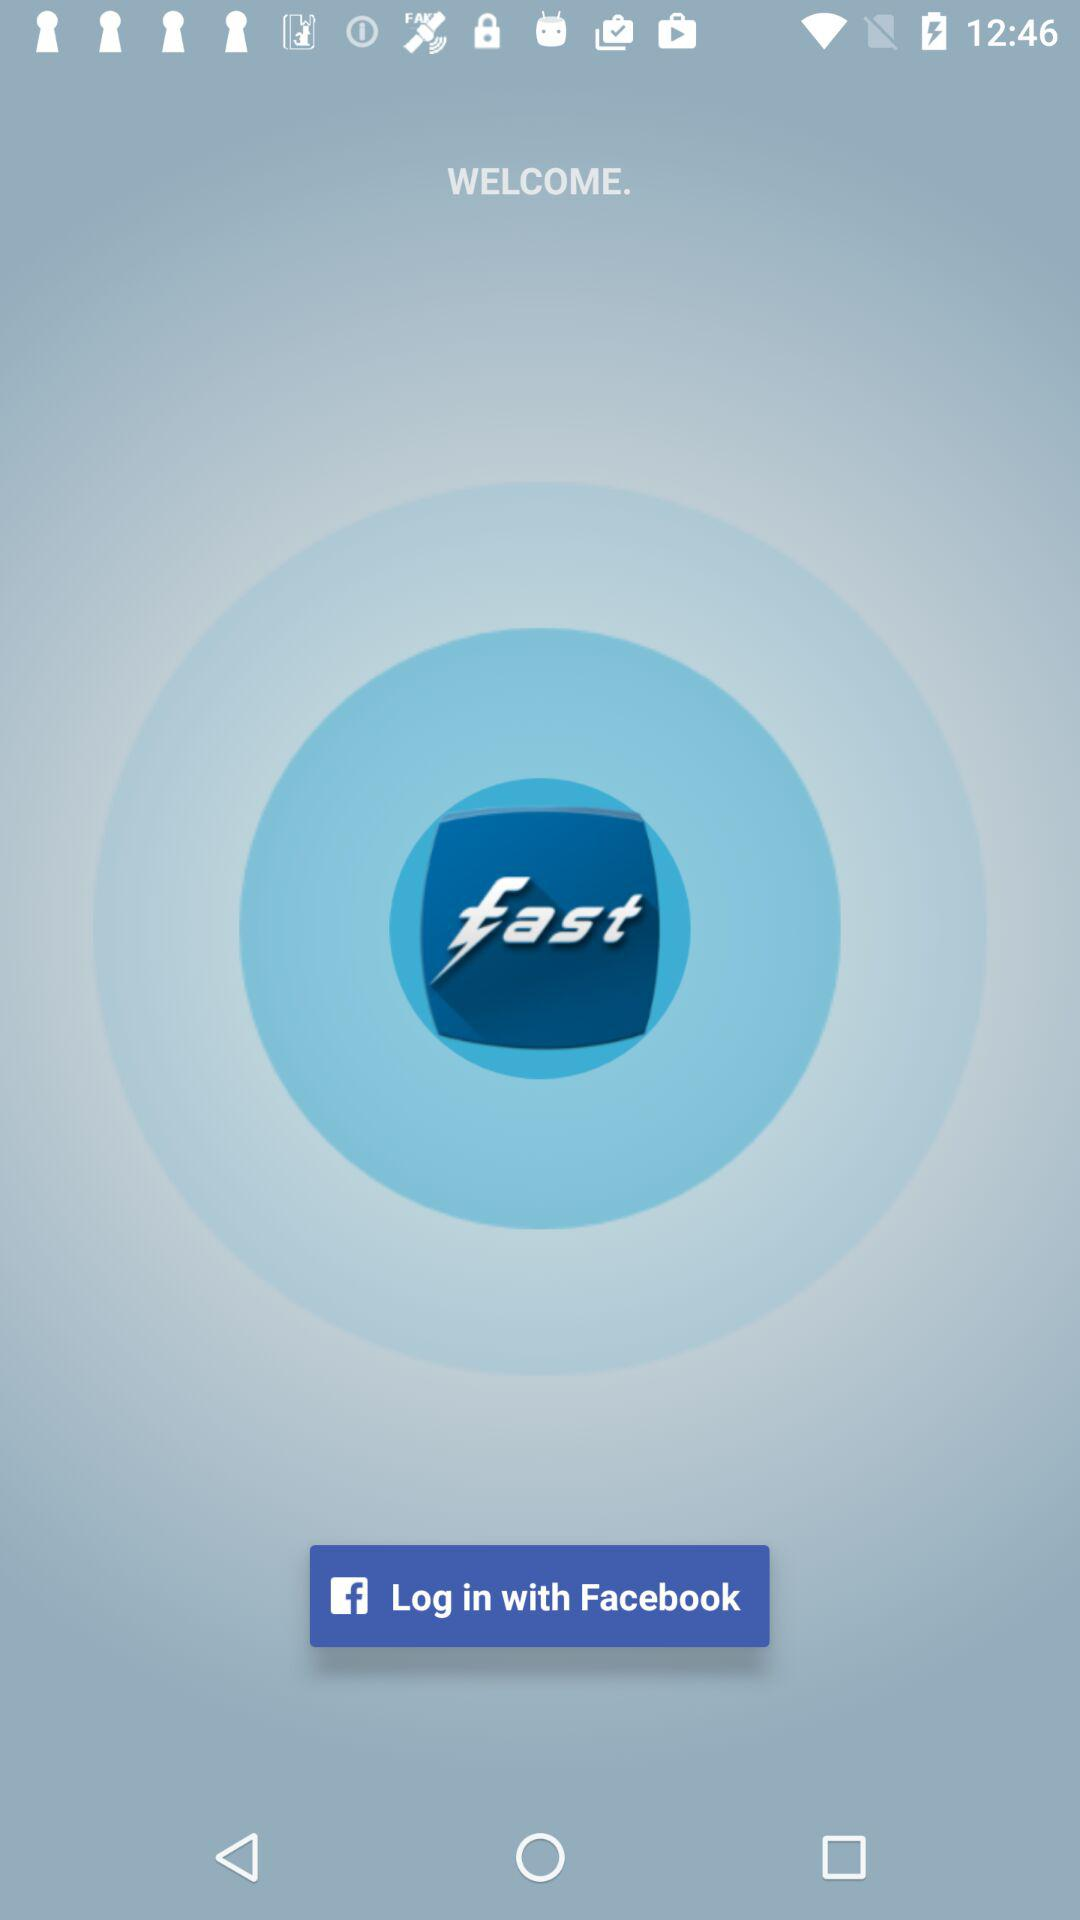With what account can logging in be done? Logging in can be done with "Facebook". 